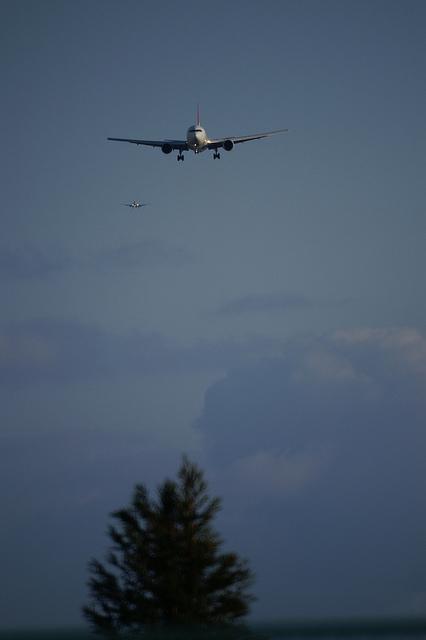How many vehicles are in this picture?
Give a very brief answer. 1. 